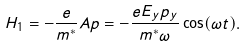<formula> <loc_0><loc_0><loc_500><loc_500>H _ { 1 } = - \frac { e } { m ^ { * } } A p = - \frac { e E _ { y } p _ { y } } { m ^ { * } \omega } \cos ( \omega t ) .</formula> 